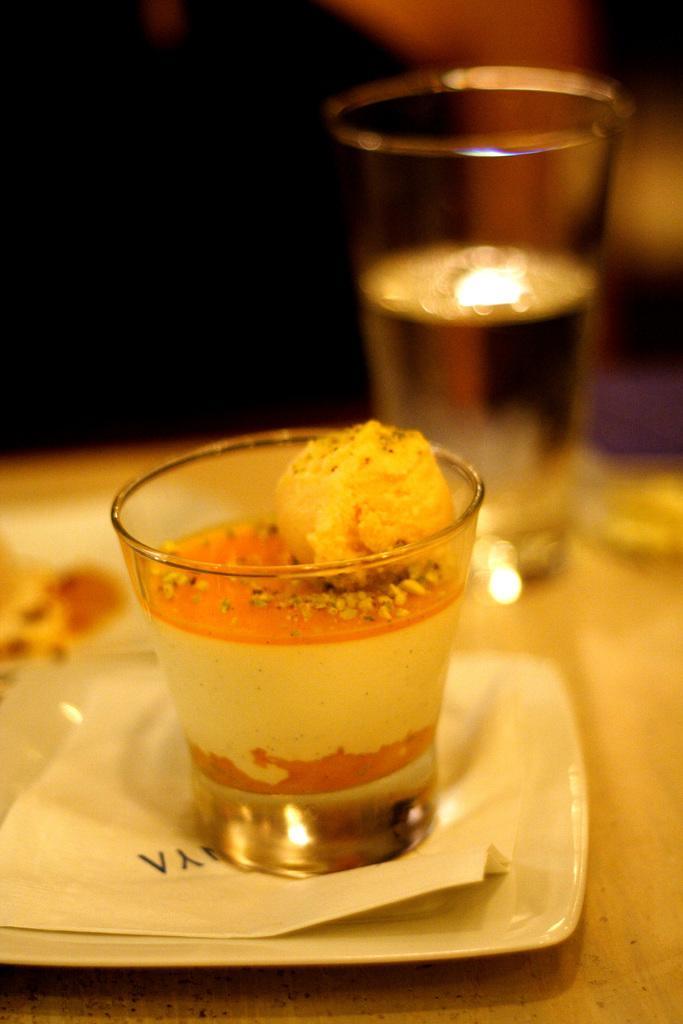Describe this image in one or two sentences. At the bottom of the image there is a table, on the table there is a plate. In the plate there is a paper and glasses. Background of the image is blur. 